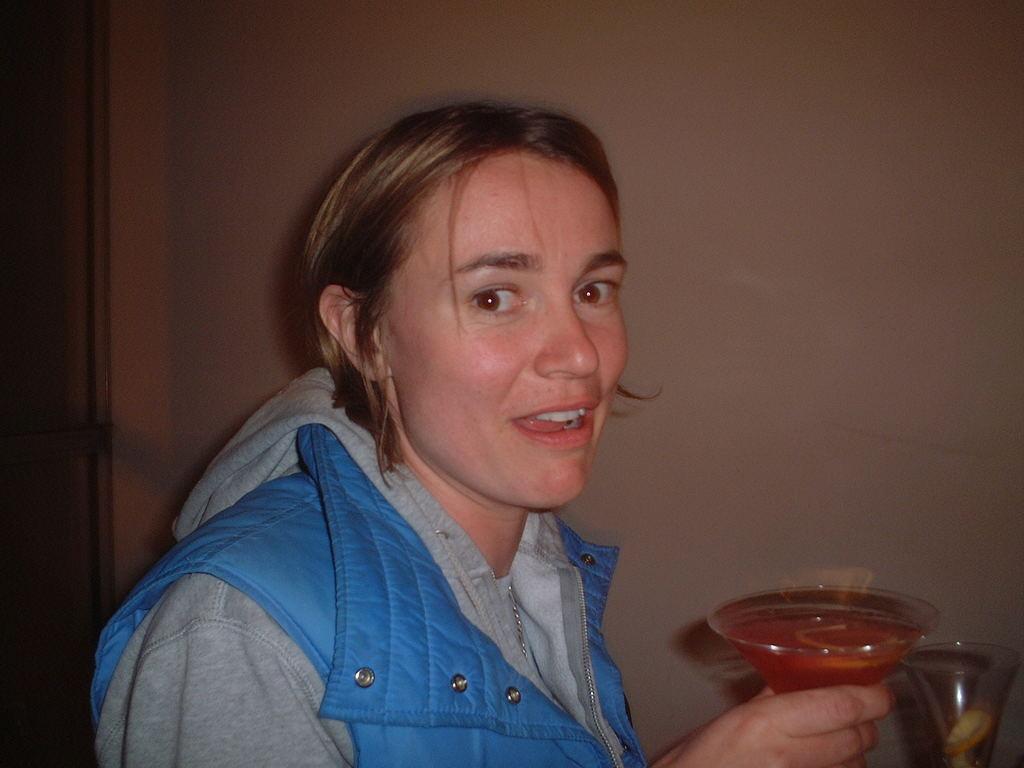Please provide a concise description of this image. In this picture we can see a woman, she is holding a glass in her hand, and we can see drink in the glass. 